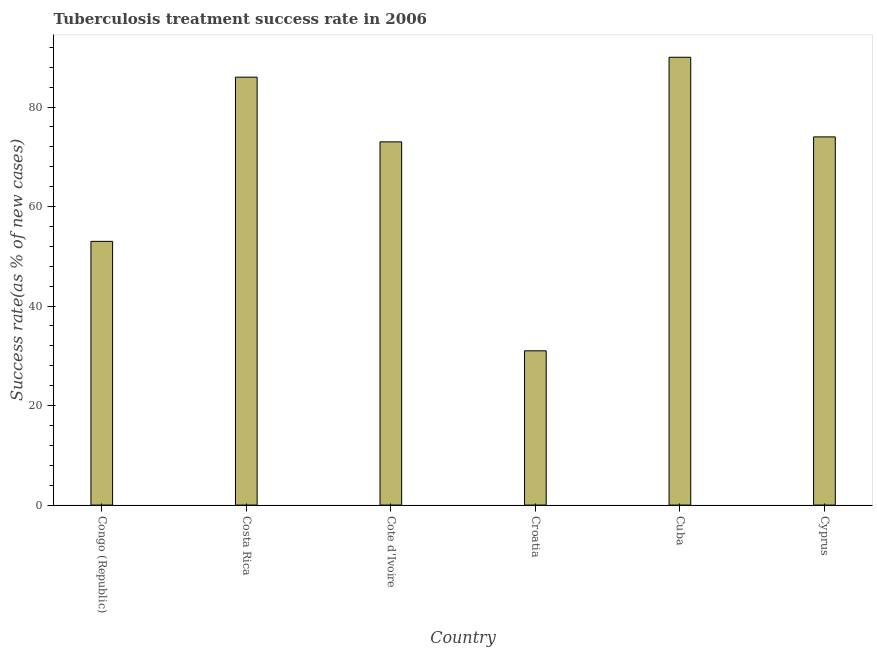Does the graph contain any zero values?
Provide a short and direct response. No. What is the title of the graph?
Ensure brevity in your answer.  Tuberculosis treatment success rate in 2006. What is the label or title of the X-axis?
Your response must be concise. Country. What is the label or title of the Y-axis?
Your answer should be very brief. Success rate(as % of new cases). What is the tuberculosis treatment success rate in Croatia?
Your response must be concise. 31. Across all countries, what is the minimum tuberculosis treatment success rate?
Give a very brief answer. 31. In which country was the tuberculosis treatment success rate maximum?
Your answer should be very brief. Cuba. In which country was the tuberculosis treatment success rate minimum?
Your answer should be compact. Croatia. What is the sum of the tuberculosis treatment success rate?
Offer a terse response. 407. What is the difference between the tuberculosis treatment success rate in Costa Rica and Cyprus?
Give a very brief answer. 12. What is the average tuberculosis treatment success rate per country?
Provide a succinct answer. 67. What is the median tuberculosis treatment success rate?
Keep it short and to the point. 73.5. What is the ratio of the tuberculosis treatment success rate in Croatia to that in Cuba?
Offer a terse response. 0.34. Is the sum of the tuberculosis treatment success rate in Croatia and Cuba greater than the maximum tuberculosis treatment success rate across all countries?
Make the answer very short. Yes. What is the difference between the highest and the lowest tuberculosis treatment success rate?
Ensure brevity in your answer.  59. In how many countries, is the tuberculosis treatment success rate greater than the average tuberculosis treatment success rate taken over all countries?
Offer a very short reply. 4. How many bars are there?
Your response must be concise. 6. Are all the bars in the graph horizontal?
Provide a short and direct response. No. Are the values on the major ticks of Y-axis written in scientific E-notation?
Provide a succinct answer. No. What is the Success rate(as % of new cases) in Costa Rica?
Your response must be concise. 86. What is the Success rate(as % of new cases) in Croatia?
Give a very brief answer. 31. What is the Success rate(as % of new cases) in Cuba?
Your answer should be compact. 90. What is the Success rate(as % of new cases) in Cyprus?
Your response must be concise. 74. What is the difference between the Success rate(as % of new cases) in Congo (Republic) and Costa Rica?
Offer a terse response. -33. What is the difference between the Success rate(as % of new cases) in Congo (Republic) and Croatia?
Provide a succinct answer. 22. What is the difference between the Success rate(as % of new cases) in Congo (Republic) and Cuba?
Make the answer very short. -37. What is the difference between the Success rate(as % of new cases) in Costa Rica and Croatia?
Give a very brief answer. 55. What is the difference between the Success rate(as % of new cases) in Costa Rica and Cyprus?
Offer a very short reply. 12. What is the difference between the Success rate(as % of new cases) in Croatia and Cuba?
Your answer should be very brief. -59. What is the difference between the Success rate(as % of new cases) in Croatia and Cyprus?
Give a very brief answer. -43. What is the difference between the Success rate(as % of new cases) in Cuba and Cyprus?
Offer a very short reply. 16. What is the ratio of the Success rate(as % of new cases) in Congo (Republic) to that in Costa Rica?
Your answer should be compact. 0.62. What is the ratio of the Success rate(as % of new cases) in Congo (Republic) to that in Cote d'Ivoire?
Your answer should be very brief. 0.73. What is the ratio of the Success rate(as % of new cases) in Congo (Republic) to that in Croatia?
Offer a very short reply. 1.71. What is the ratio of the Success rate(as % of new cases) in Congo (Republic) to that in Cuba?
Your response must be concise. 0.59. What is the ratio of the Success rate(as % of new cases) in Congo (Republic) to that in Cyprus?
Ensure brevity in your answer.  0.72. What is the ratio of the Success rate(as % of new cases) in Costa Rica to that in Cote d'Ivoire?
Give a very brief answer. 1.18. What is the ratio of the Success rate(as % of new cases) in Costa Rica to that in Croatia?
Give a very brief answer. 2.77. What is the ratio of the Success rate(as % of new cases) in Costa Rica to that in Cuba?
Offer a terse response. 0.96. What is the ratio of the Success rate(as % of new cases) in Costa Rica to that in Cyprus?
Make the answer very short. 1.16. What is the ratio of the Success rate(as % of new cases) in Cote d'Ivoire to that in Croatia?
Provide a short and direct response. 2.35. What is the ratio of the Success rate(as % of new cases) in Cote d'Ivoire to that in Cuba?
Offer a very short reply. 0.81. What is the ratio of the Success rate(as % of new cases) in Cote d'Ivoire to that in Cyprus?
Offer a terse response. 0.99. What is the ratio of the Success rate(as % of new cases) in Croatia to that in Cuba?
Provide a short and direct response. 0.34. What is the ratio of the Success rate(as % of new cases) in Croatia to that in Cyprus?
Your response must be concise. 0.42. What is the ratio of the Success rate(as % of new cases) in Cuba to that in Cyprus?
Offer a very short reply. 1.22. 